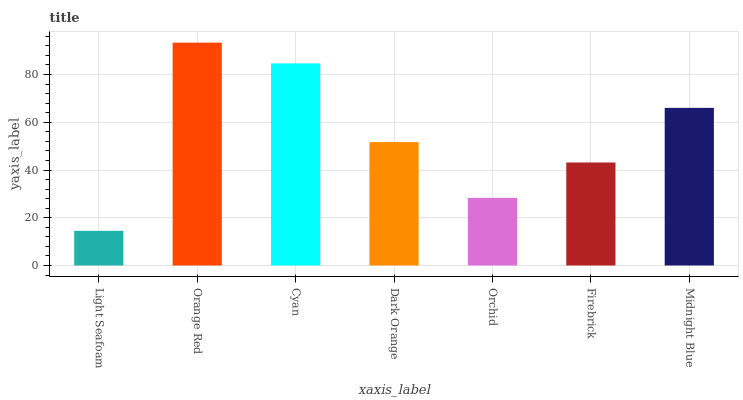Is Light Seafoam the minimum?
Answer yes or no. Yes. Is Orange Red the maximum?
Answer yes or no. Yes. Is Cyan the minimum?
Answer yes or no. No. Is Cyan the maximum?
Answer yes or no. No. Is Orange Red greater than Cyan?
Answer yes or no. Yes. Is Cyan less than Orange Red?
Answer yes or no. Yes. Is Cyan greater than Orange Red?
Answer yes or no. No. Is Orange Red less than Cyan?
Answer yes or no. No. Is Dark Orange the high median?
Answer yes or no. Yes. Is Dark Orange the low median?
Answer yes or no. Yes. Is Firebrick the high median?
Answer yes or no. No. Is Light Seafoam the low median?
Answer yes or no. No. 